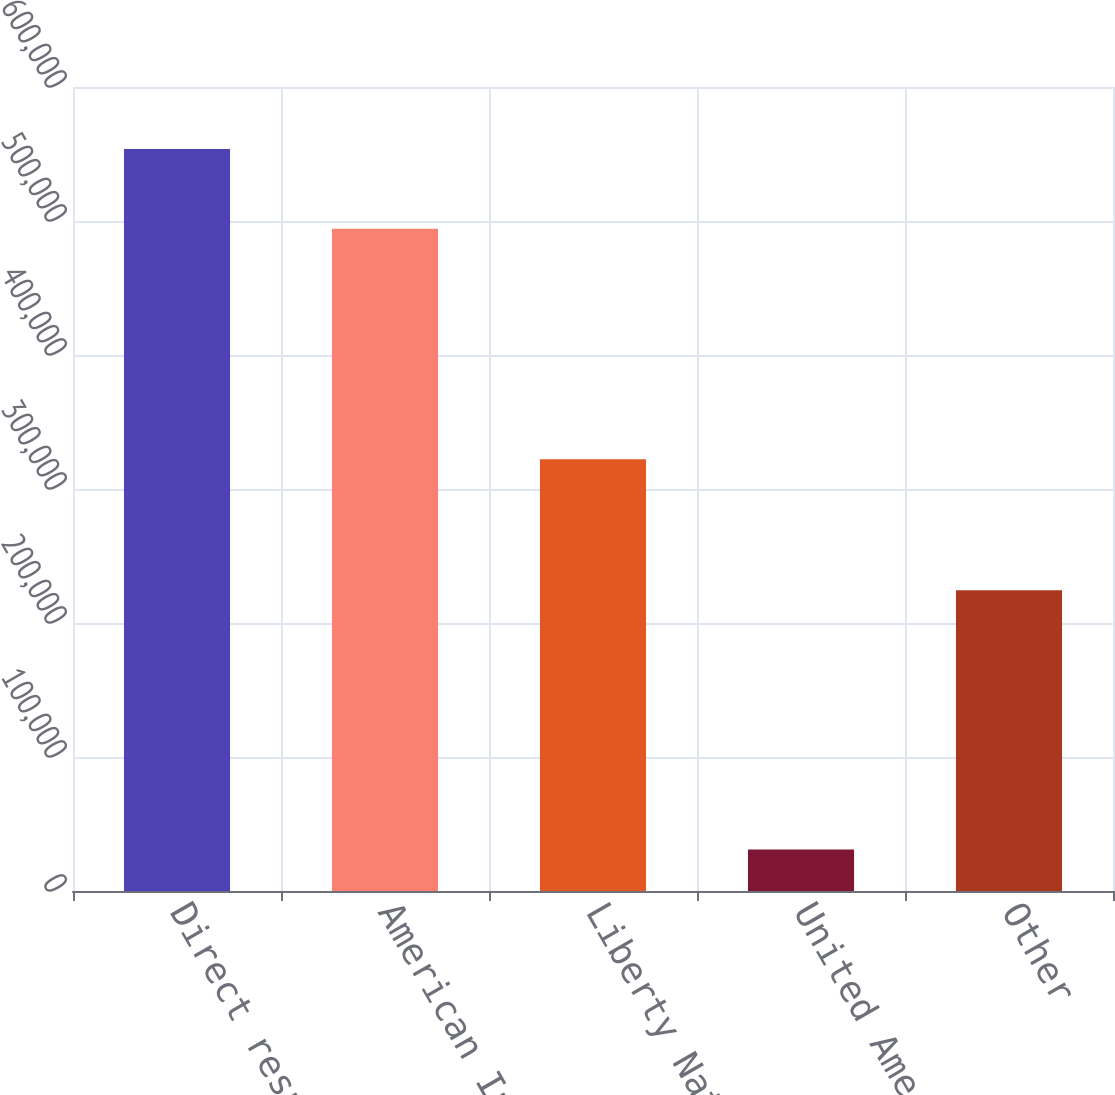<chart> <loc_0><loc_0><loc_500><loc_500><bar_chart><fcel>Direct response<fcel>American Income<fcel>Liberty National<fcel>United American<fcel>Other<nl><fcel>553740<fcel>494191<fcel>322179<fcel>30998<fcel>224441<nl></chart> 